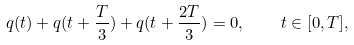<formula> <loc_0><loc_0><loc_500><loc_500>q ( t ) + q ( t + \frac { T } { 3 } ) + q ( t + \frac { 2 T } { 3 } ) = 0 , \quad t \in [ 0 , T ] ,</formula> 